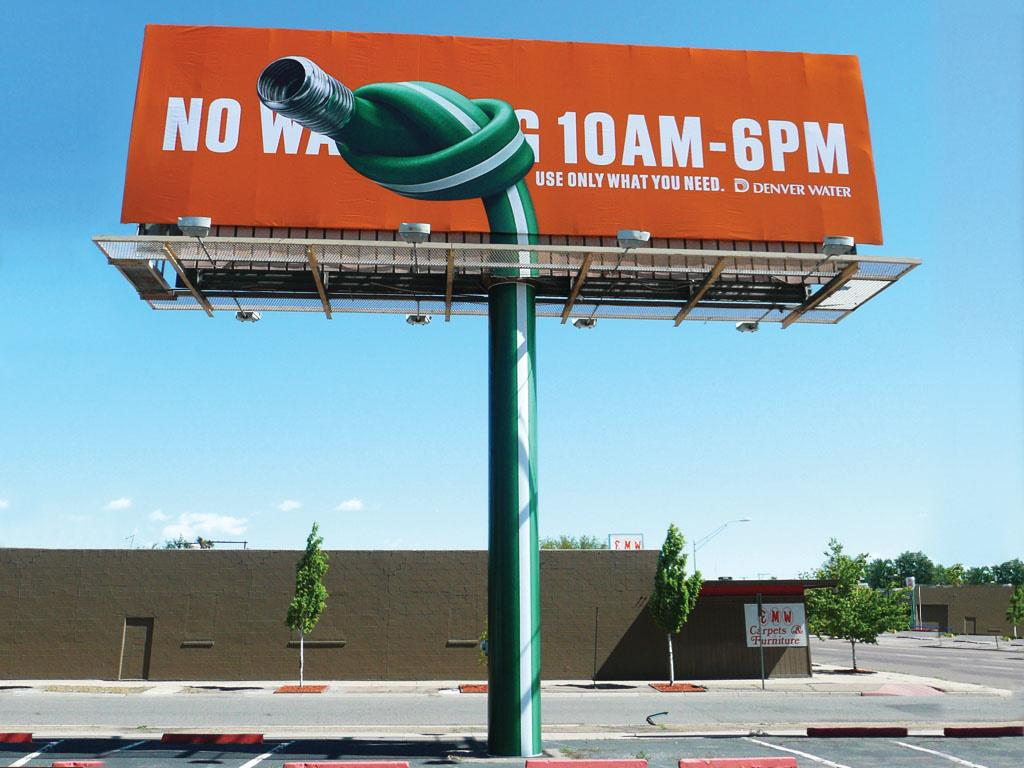What is the main object in the image? There is a board in the image. What else can be seen in the image besides the board? There is a pipeline visible in the image. What can be seen in the background of the image? There are trees and a wall in the background of the image. What type of paper is being used to build the harbor in the image? There is no harbor present in the image, and therefore no paper being used to build it. 